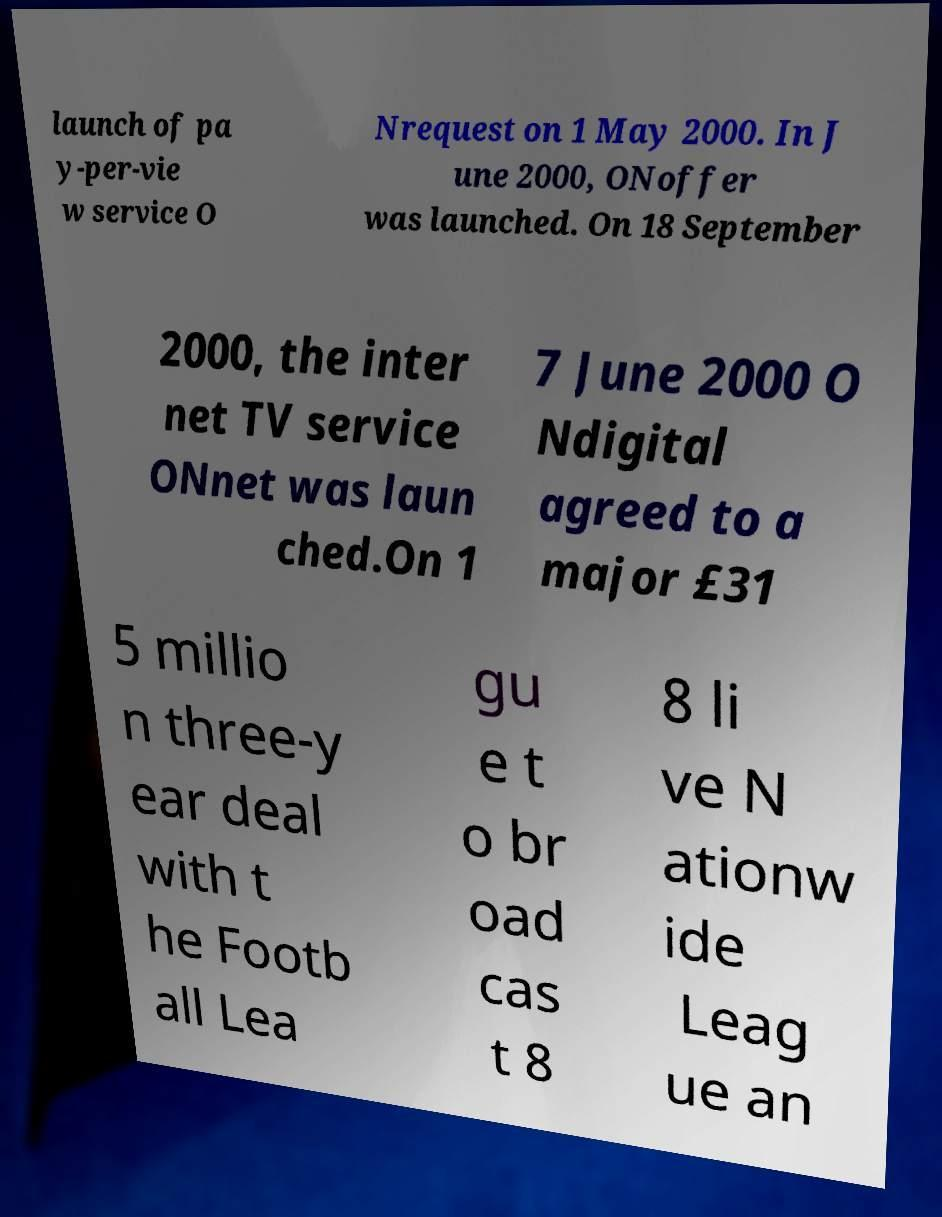Can you read and provide the text displayed in the image?This photo seems to have some interesting text. Can you extract and type it out for me? launch of pa y-per-vie w service O Nrequest on 1 May 2000. In J une 2000, ONoffer was launched. On 18 September 2000, the inter net TV service ONnet was laun ched.On 1 7 June 2000 O Ndigital agreed to a major £31 5 millio n three-y ear deal with t he Footb all Lea gu e t o br oad cas t 8 8 li ve N ationw ide Leag ue an 